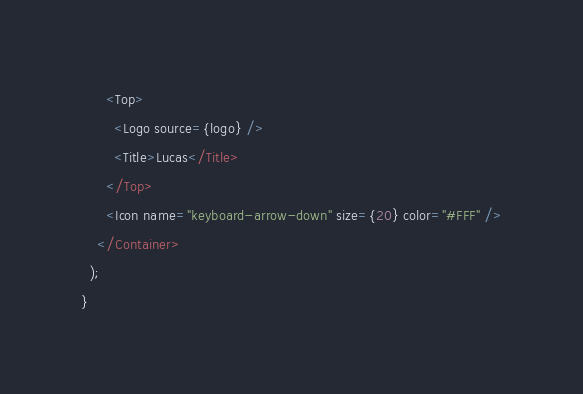Convert code to text. <code><loc_0><loc_0><loc_500><loc_500><_JavaScript_>      <Top>
        <Logo source={logo} />
        <Title>Lucas</Title>
      </Top>
      <Icon name="keyboard-arrow-down" size={20} color="#FFF" />
    </Container>
  );
}
</code> 